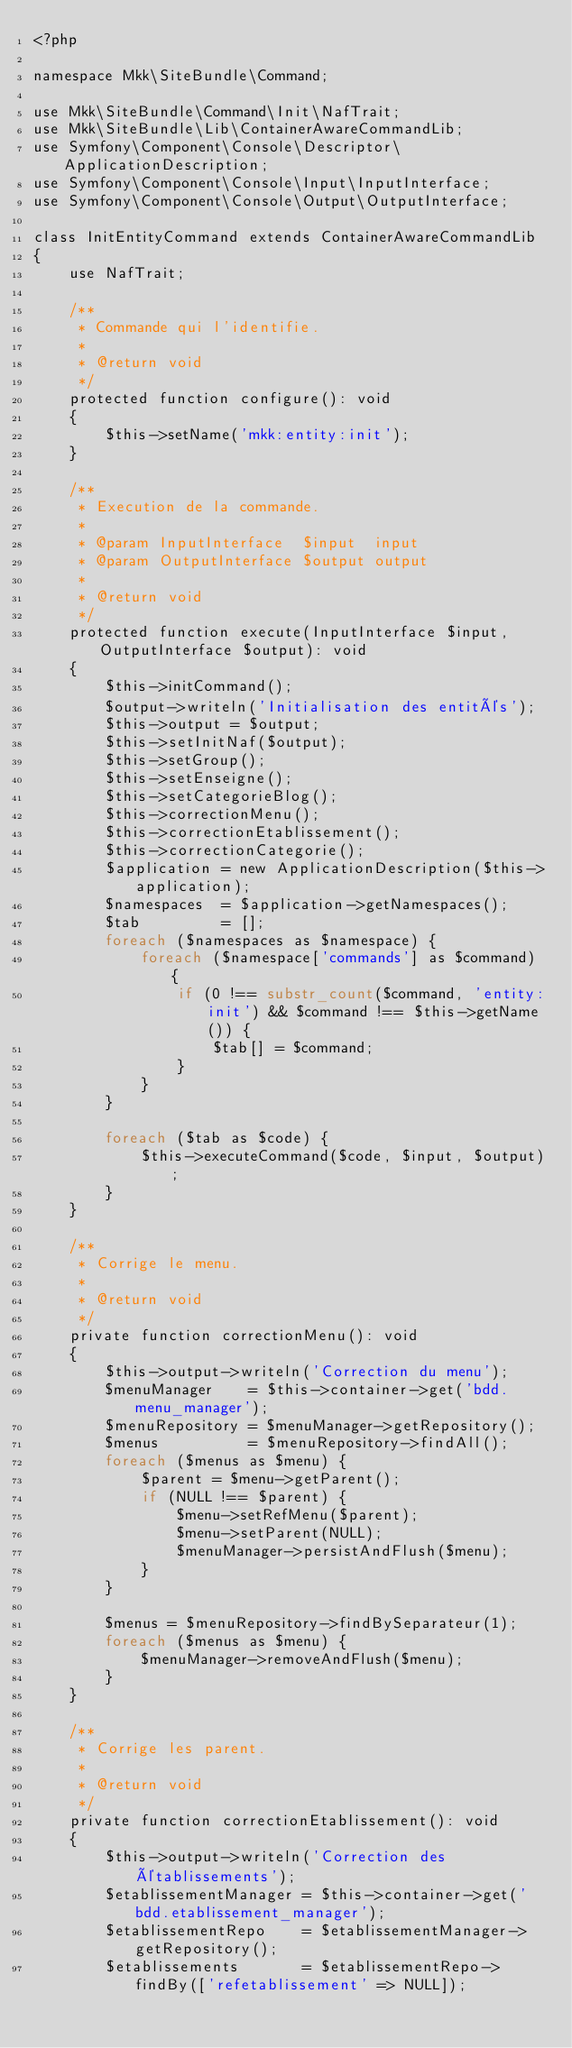Convert code to text. <code><loc_0><loc_0><loc_500><loc_500><_PHP_><?php

namespace Mkk\SiteBundle\Command;

use Mkk\SiteBundle\Command\Init\NafTrait;
use Mkk\SiteBundle\Lib\ContainerAwareCommandLib;
use Symfony\Component\Console\Descriptor\ApplicationDescription;
use Symfony\Component\Console\Input\InputInterface;
use Symfony\Component\Console\Output\OutputInterface;

class InitEntityCommand extends ContainerAwareCommandLib
{
    use NafTrait;

    /**
     * Commande qui l'identifie.
     *
     * @return void
     */
    protected function configure(): void
    {
        $this->setName('mkk:entity:init');
    }

    /**
     * Execution de la commande.
     *
     * @param InputInterface  $input  input
     * @param OutputInterface $output output
     *
     * @return void
     */
    protected function execute(InputInterface $input, OutputInterface $output): void
    {
        $this->initCommand();
        $output->writeln('Initialisation des entités');
        $this->output = $output;
        $this->setInitNaf($output);
        $this->setGroup();
        $this->setEnseigne();
        $this->setCategorieBlog();
        $this->correctionMenu();
        $this->correctionEtablissement();
        $this->correctionCategorie();
        $application = new ApplicationDescription($this->application);
        $namespaces  = $application->getNamespaces();
        $tab         = [];
        foreach ($namespaces as $namespace) {
            foreach ($namespace['commands'] as $command) {
                if (0 !== substr_count($command, 'entity:init') && $command !== $this->getName()) {
                    $tab[] = $command;
                }
            }
        }

        foreach ($tab as $code) {
            $this->executeCommand($code, $input, $output);
        }
    }

    /**
     * Corrige le menu.
     *
     * @return void
     */
    private function correctionMenu(): void
    {
        $this->output->writeln('Correction du menu');
        $menuManager    = $this->container->get('bdd.menu_manager');
        $menuRepository = $menuManager->getRepository();
        $menus          = $menuRepository->findAll();
        foreach ($menus as $menu) {
            $parent = $menu->getParent();
            if (NULL !== $parent) {
                $menu->setRefMenu($parent);
                $menu->setParent(NULL);
                $menuManager->persistAndFlush($menu);
            }
        }

        $menus = $menuRepository->findBySeparateur(1);
        foreach ($menus as $menu) {
            $menuManager->removeAndFlush($menu);
        }
    }

    /**
     * Corrige les parent.
     *
     * @return void
     */
    private function correctionEtablissement(): void
    {
        $this->output->writeln('Correction des établissements');
        $etablissementManager = $this->container->get('bdd.etablissement_manager');
        $etablissementRepo    = $etablissementManager->getRepository();
        $etablissements       = $etablissementRepo->findBy(['refetablissement' => NULL]);</code> 